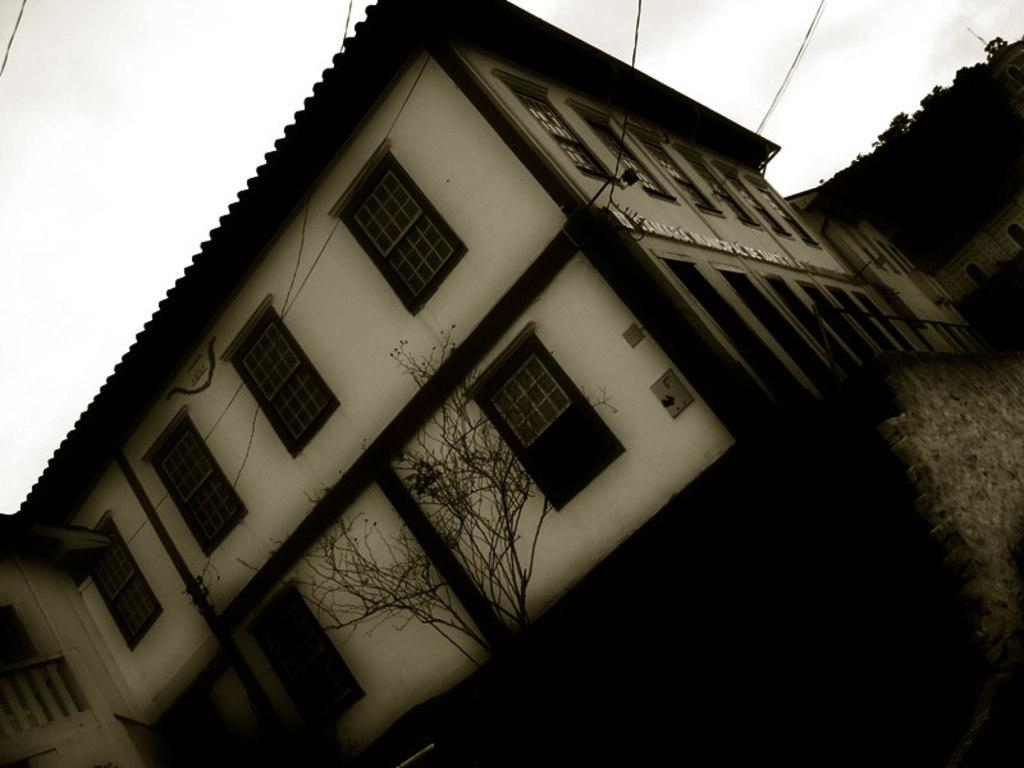What can be seen in the sky in the image? The sky is visible in the image. What type of structure is present in the image? There is a building in the image. What are the transmission wires used for in the image? Transmission wires are present in the image, but their purpose is not explicitly stated. How many windows are visible in the image? There are windows in the image. What type of vegetation is present in the image? There is a tree in the image. What part of the image is dark? The right side portion of the image is completely dark. Can you see a screw holding the tree in place in the image? There is no screw visible in the image, and the tree is not shown to be held in place by any visible means. What type of straw is being used to drink from the sky in the image? There is no straw present in the image, and the sky is not depicted as a liquid that could be consumed. 